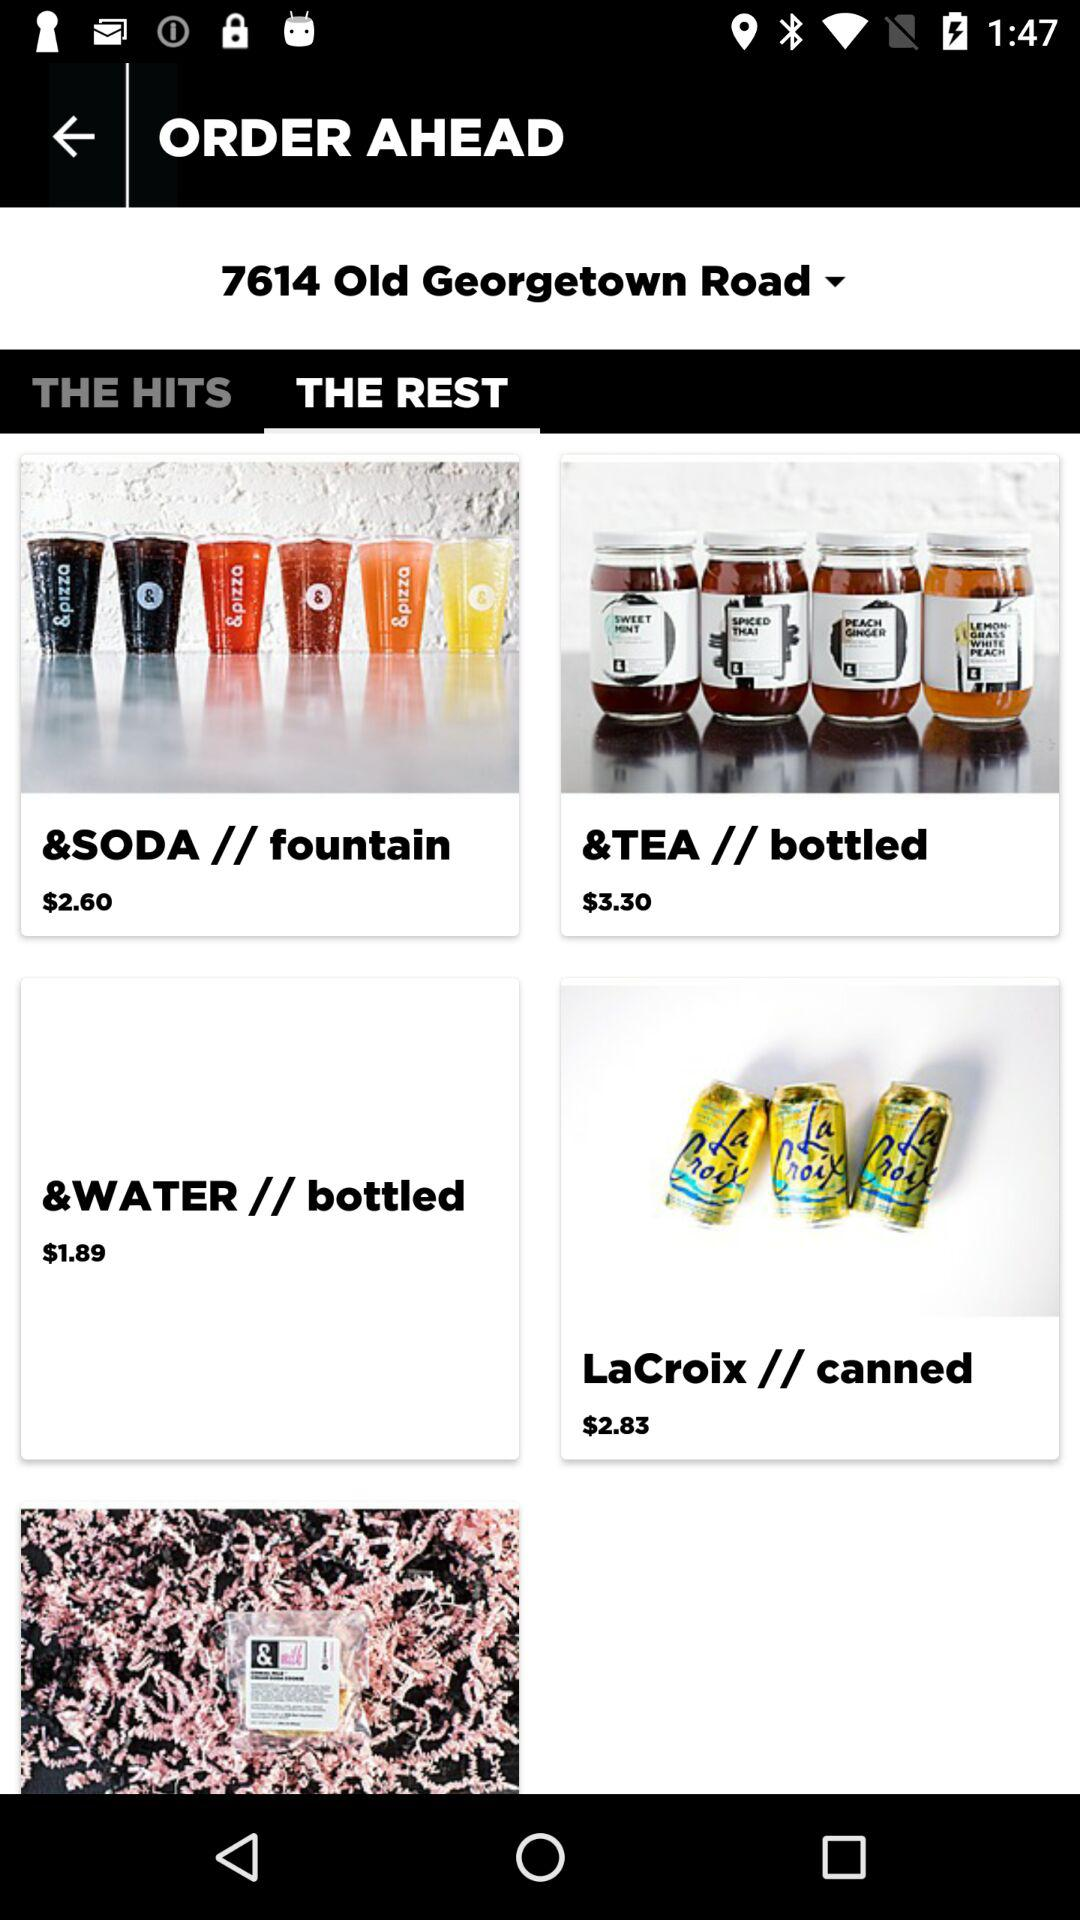What is the price for "LaCroix // canned"? The price is $2.83. 